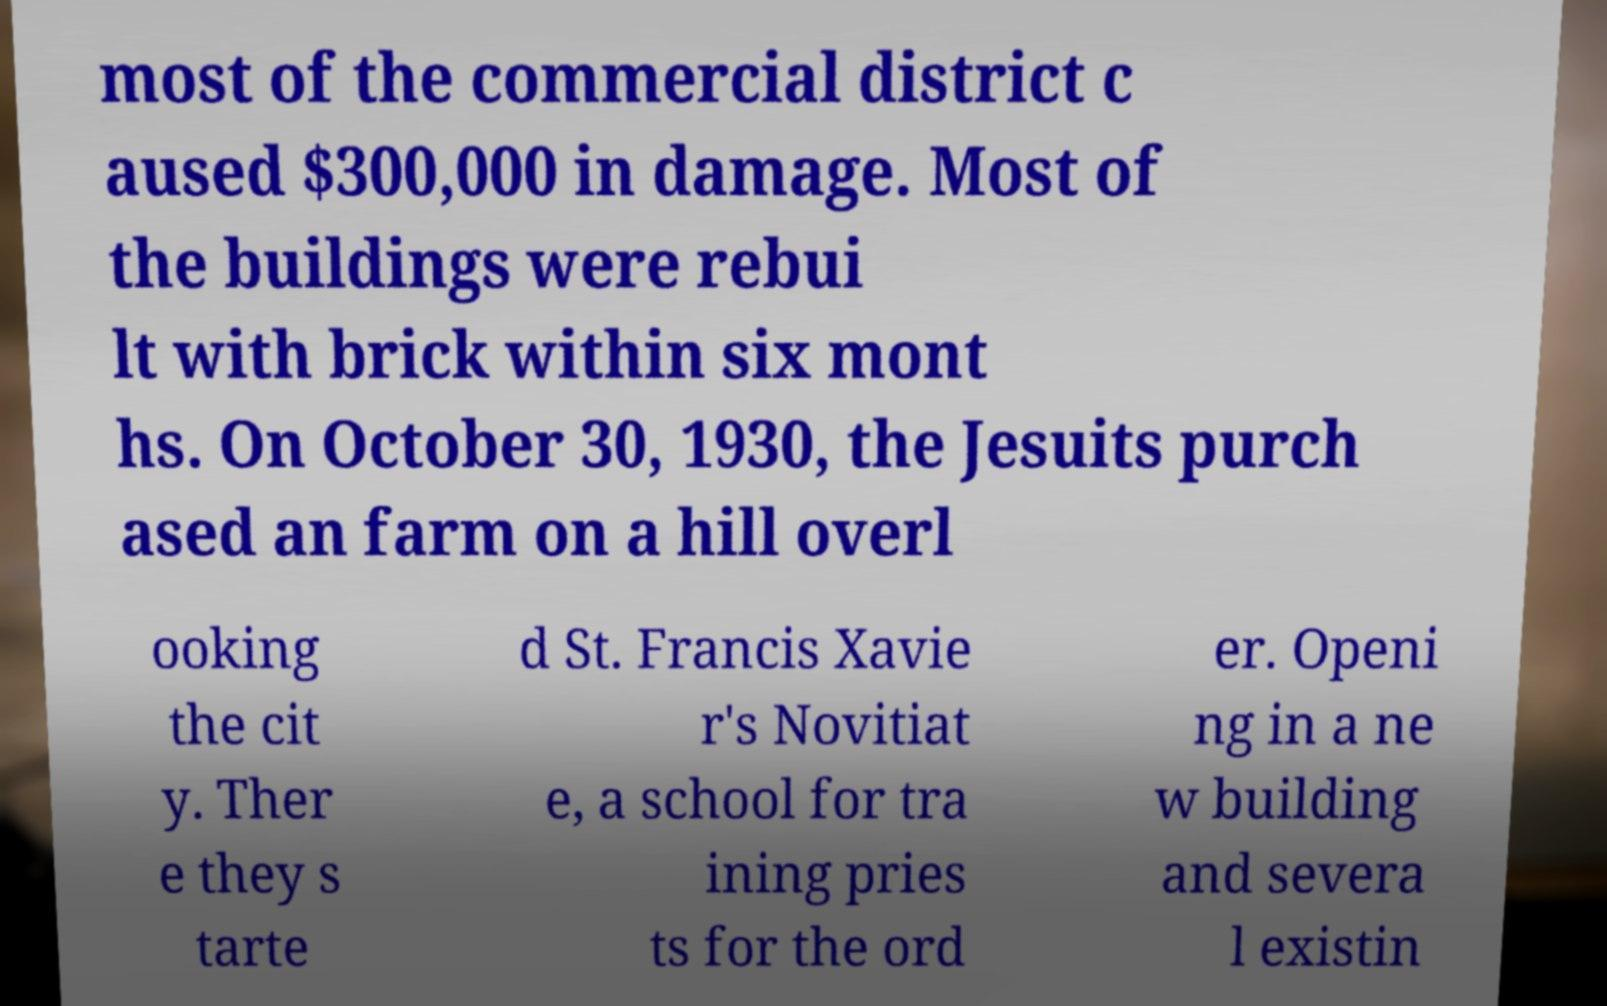Could you assist in decoding the text presented in this image and type it out clearly? most of the commercial district c aused $300,000 in damage. Most of the buildings were rebui lt with brick within six mont hs. On October 30, 1930, the Jesuits purch ased an farm on a hill overl ooking the cit y. Ther e they s tarte d St. Francis Xavie r's Novitiat e, a school for tra ining pries ts for the ord er. Openi ng in a ne w building and severa l existin 